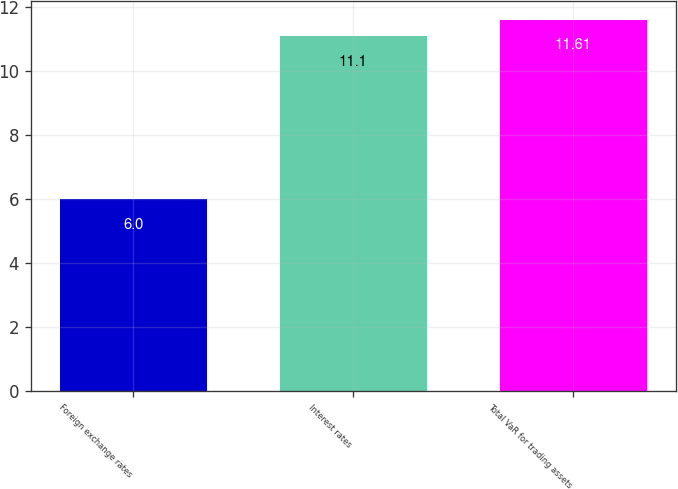<chart> <loc_0><loc_0><loc_500><loc_500><bar_chart><fcel>Foreign exchange rates<fcel>Interest rates<fcel>Total VaR for trading assets<nl><fcel>6<fcel>11.1<fcel>11.61<nl></chart> 